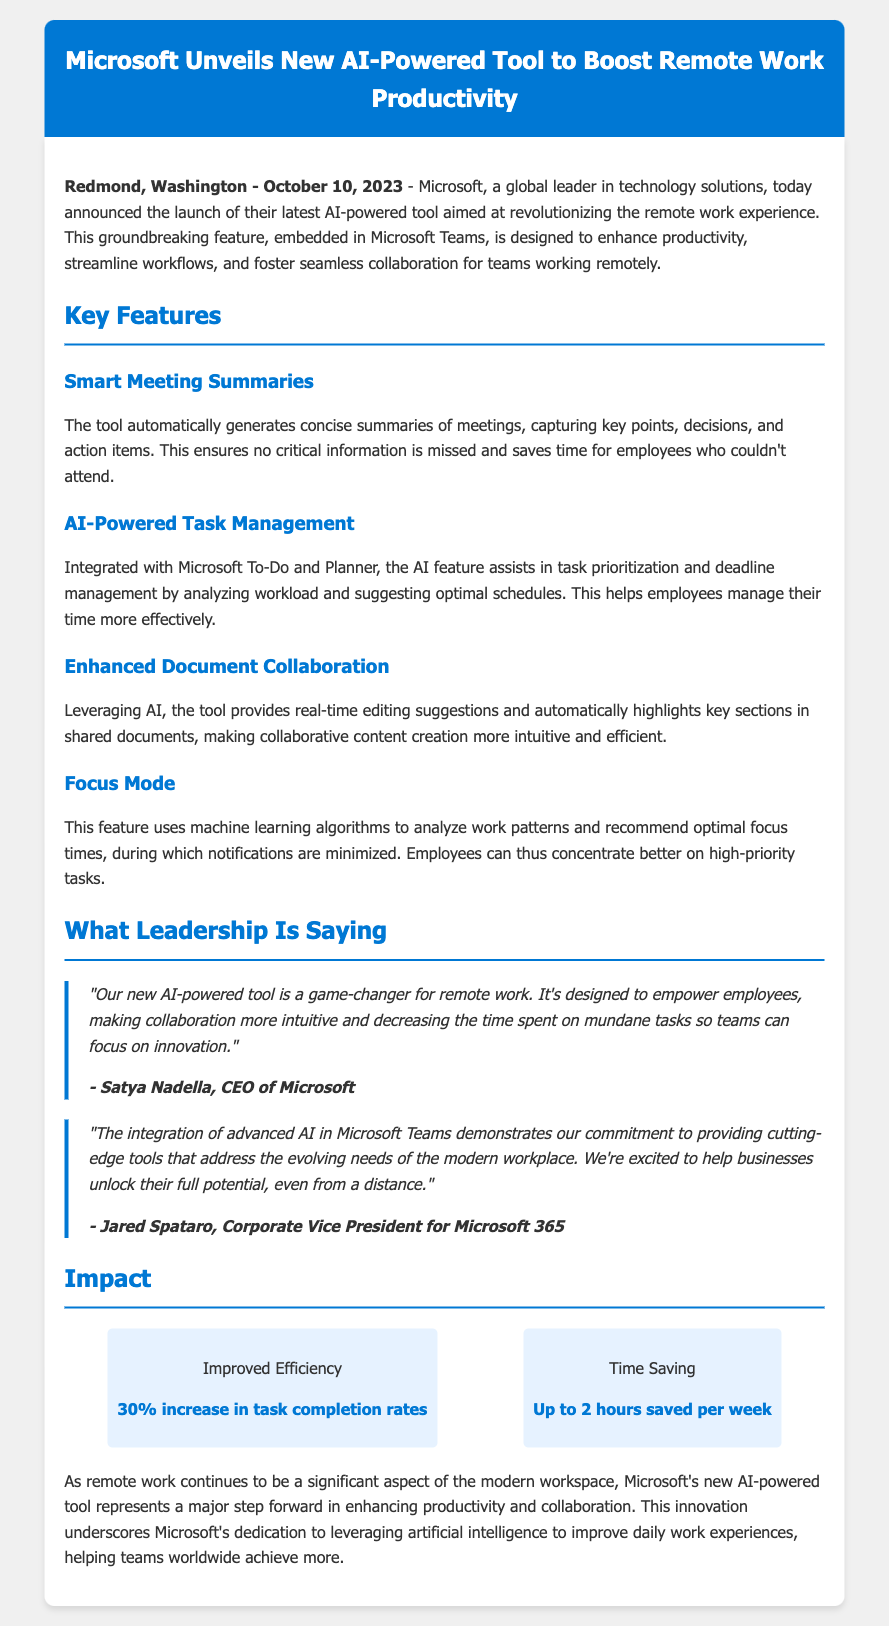what is the launch date of the AI tool? The launch date mentioned in the document is October 10, 2023.
Answer: October 10, 2023 who is the CEO of Microsoft? The document states that the CEO of Microsoft is Satya Nadella.
Answer: Satya Nadella what feature helps in managing deadlines? The feature that assists in task prioritization and deadline management is AI-Powered Task Management.
Answer: AI-Powered Task Management how much time can be saved per week using the tool? The document mentions that users can save up to 2 hours per week using the tool.
Answer: Up to 2 hours what is the percentage increase in task completion rates? According to the document, there is a 30% increase in task completion rates.
Answer: 30% why is the AI tool considered a game-changer? It is considered a game-changer for its ability to empower employees and make collaboration more intuitive.
Answer: Empower employees and make collaboration more intuitive what company is launching the AI-powered tool? The company mentioned in the document that is launching the tool is Microsoft.
Answer: Microsoft what does the Focus Mode feature help with? The Focus Mode feature helps employees concentrate better on high-priority tasks.
Answer: Concentrate better on high-priority tasks 